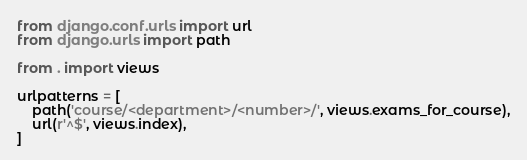<code> <loc_0><loc_0><loc_500><loc_500><_Python_>from django.conf.urls import url
from django.urls import path

from . import views

urlpatterns = [
	path('course/<department>/<number>/', views.exams_for_course),
    url(r'^$', views.index),
]</code> 